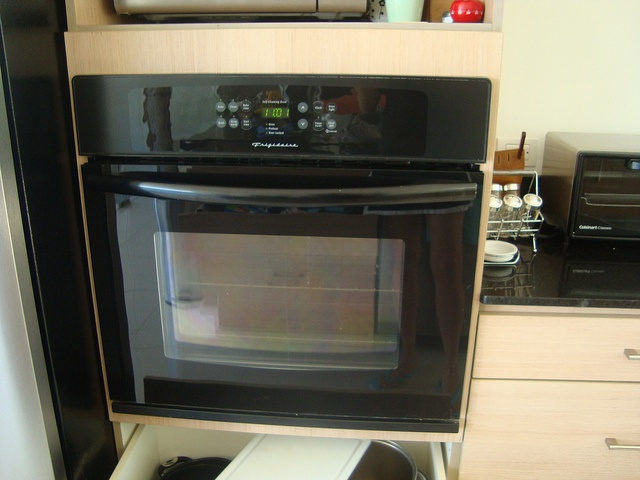Describe the objects in this image and their specific colors. I can see oven in black, gray, darkgray, and darkgreen tones, microwave in black and gray tones, bowl in black, beige, darkgray, and gray tones, cup in black, gray, and beige tones, and cup in black, gray, beige, and darkgreen tones in this image. 